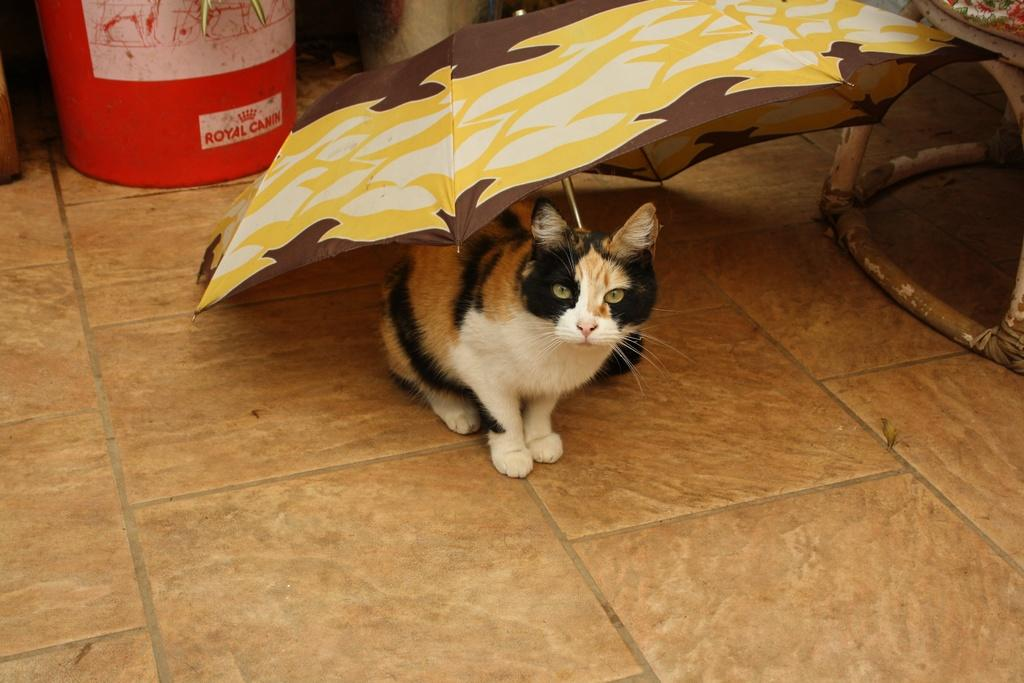What is on the ground in the image? There is an animal, an umbrella, and a container on the ground. Can you describe the animal in the image? The animal is not specified in the facts, so we cannot provide a description. What is the purpose of the umbrella on the ground? The purpose of the umbrella is not specified in the facts, so we cannot determine its purpose. What might be inside the container on the ground? The contents of the container are not specified in the facts, so we cannot determine what is inside. What type of guide is present in the image? There is no guide present in the image. Can you describe the argument between the icicles in the image? There are no icicles present in the image, so there cannot be an argument between them. 